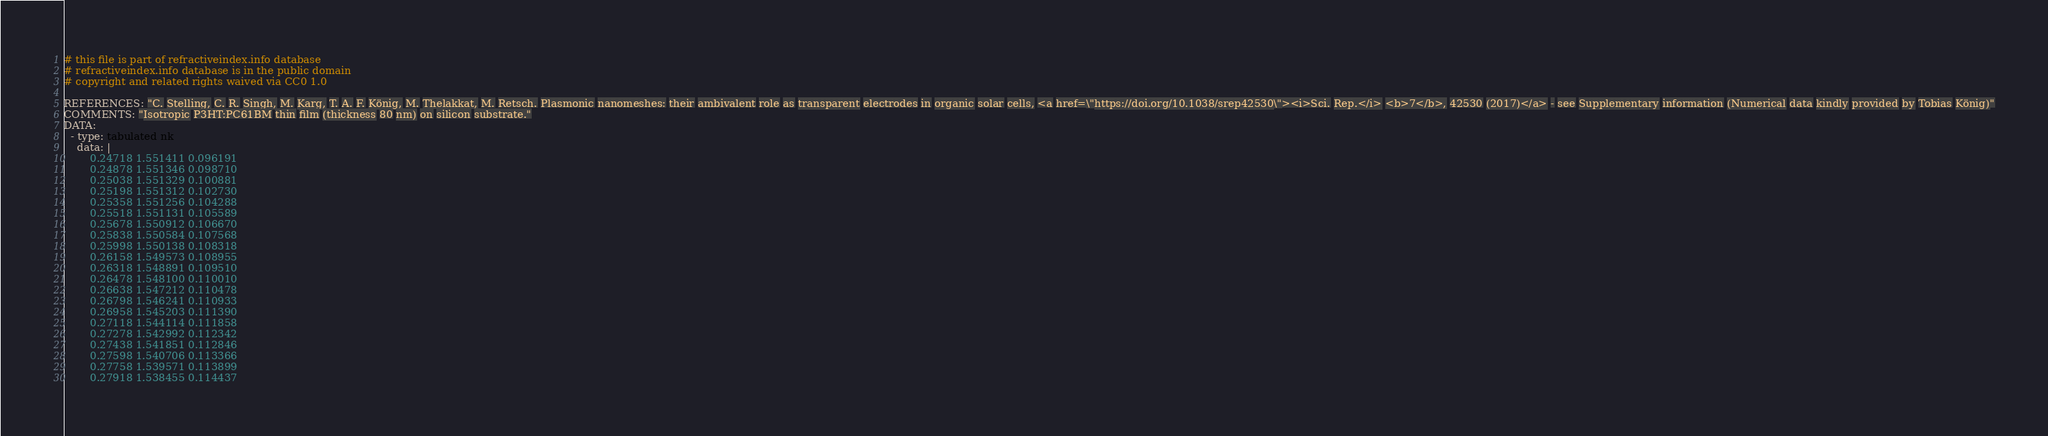<code> <loc_0><loc_0><loc_500><loc_500><_YAML_># this file is part of refractiveindex.info database
# refractiveindex.info database is in the public domain
# copyright and related rights waived via CC0 1.0

REFERENCES: "C. Stelling, C. R. Singh, M. Karg, T. A. F. König, M. Thelakkat, M. Retsch. Plasmonic nanomeshes: their ambivalent role as transparent electrodes in organic solar cells, <a href=\"https://doi.org/10.1038/srep42530\"><i>Sci. Rep.</i> <b>7</b>, 42530 (2017)</a> - see Supplementary information (Numerical data kindly provided by Tobias König)"
COMMENTS: "Isotropic P3HT:PC61BM thin film (thickness 80 nm) on silicon substrate."
DATA:
  - type: tabulated nk
    data: |
        0.24718 1.551411 0.096191
        0.24878 1.551346 0.098710
        0.25038 1.551329 0.100881
        0.25198 1.551312 0.102730
        0.25358 1.551256 0.104288
        0.25518 1.551131 0.105589
        0.25678 1.550912 0.106670
        0.25838 1.550584 0.107568
        0.25998 1.550138 0.108318
        0.26158 1.549573 0.108955
        0.26318 1.548891 0.109510
        0.26478 1.548100 0.110010
        0.26638 1.547212 0.110478
        0.26798 1.546241 0.110933
        0.26958 1.545203 0.111390
        0.27118 1.544114 0.111858
        0.27278 1.542992 0.112342
        0.27438 1.541851 0.112846
        0.27598 1.540706 0.113366
        0.27758 1.539571 0.113899
        0.27918 1.538455 0.114437</code> 